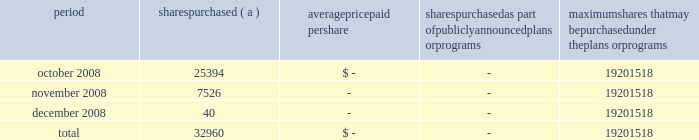Annual report on form 10-k 108 fifth third bancorp part ii item 5 .
Market for registrant 2019s common equity , related stockholder matters and issuer purchases of equity securities the information required by this item is included in the corporate information found on the inside of the back cover and in the discussion of dividend limitations that the subsidiaries can pay to the bancorp discussed in note 26 of the notes to the consolidated financial statements .
Additionally , as of december 31 , 2008 , the bancorp had approximately 60025 shareholders of record .
Issuer purchases of equity securities period shares purchased average paid per shares purchased as part of publicly announced plans or programs maximum shares that may be purchased under the plans or programs .
( a ) the bancorp repurchased 25394 , 7526 and 40 shares during october , november and december of 2008 in connection with various employee compensation plans of the bancorp .
These purchases are not included against the maximum number of shares that may yet be purchased under the board of directors authorization. .
What portion of the total purchased shares presented in the table was purchased during november 2008? 
Computations: (7526 / 32960)
Answer: 0.22834. 